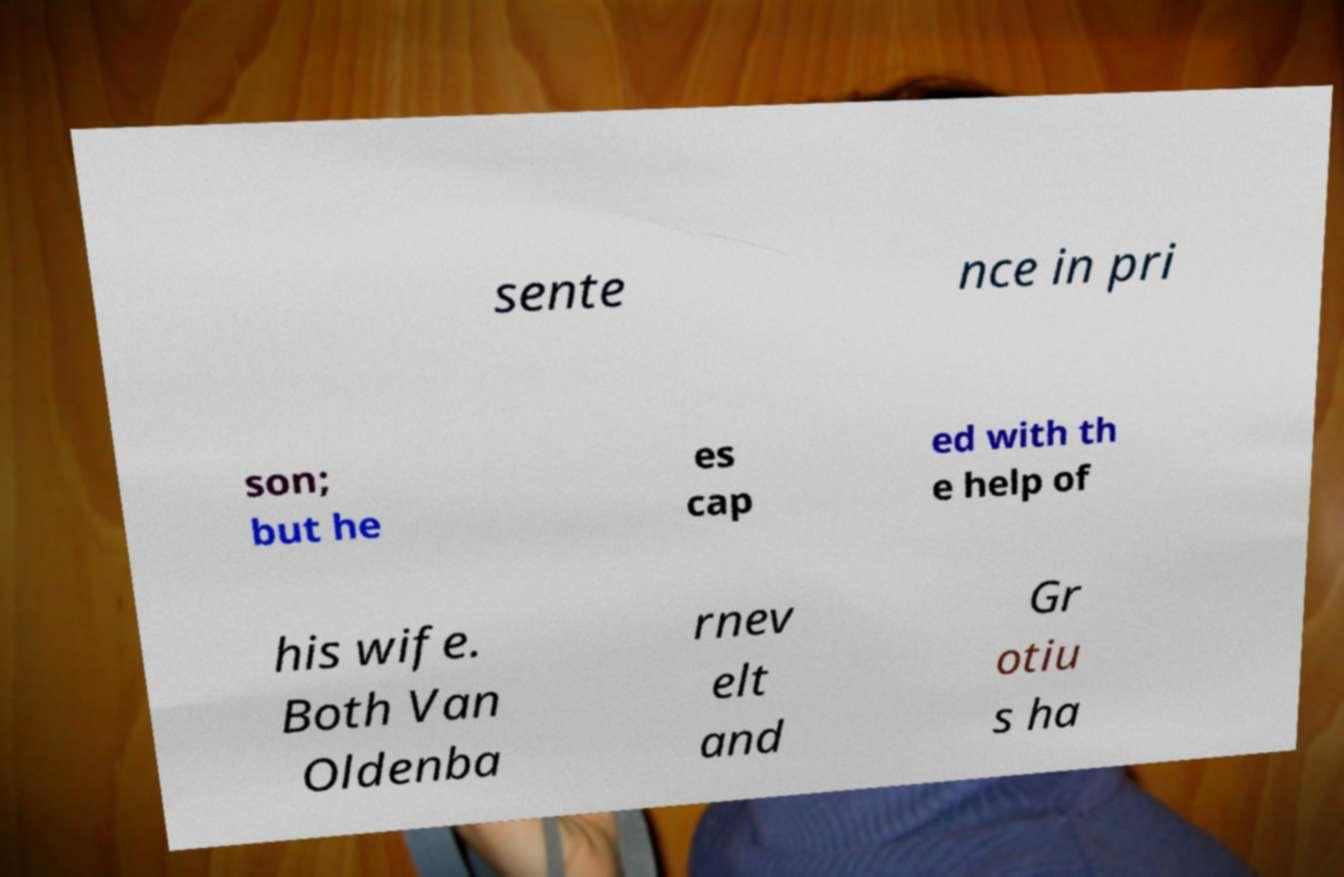For documentation purposes, I need the text within this image transcribed. Could you provide that? sente nce in pri son; but he es cap ed with th e help of his wife. Both Van Oldenba rnev elt and Gr otiu s ha 